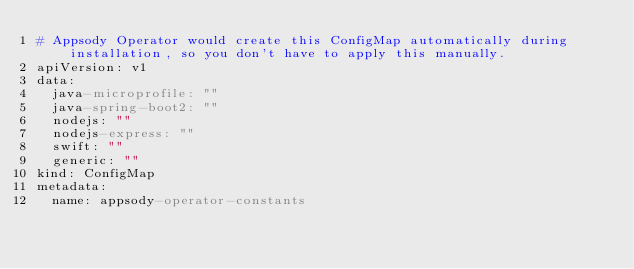Convert code to text. <code><loc_0><loc_0><loc_500><loc_500><_YAML_># Appsody Operator would create this ConfigMap automatically during installation, so you don't have to apply this manually.
apiVersion: v1
data:
  java-microprofile: ""
  java-spring-boot2: ""
  nodejs: ""
  nodejs-express: ""
  swift: ""
  generic: ""
kind: ConfigMap
metadata:
  name: appsody-operator-constants</code> 